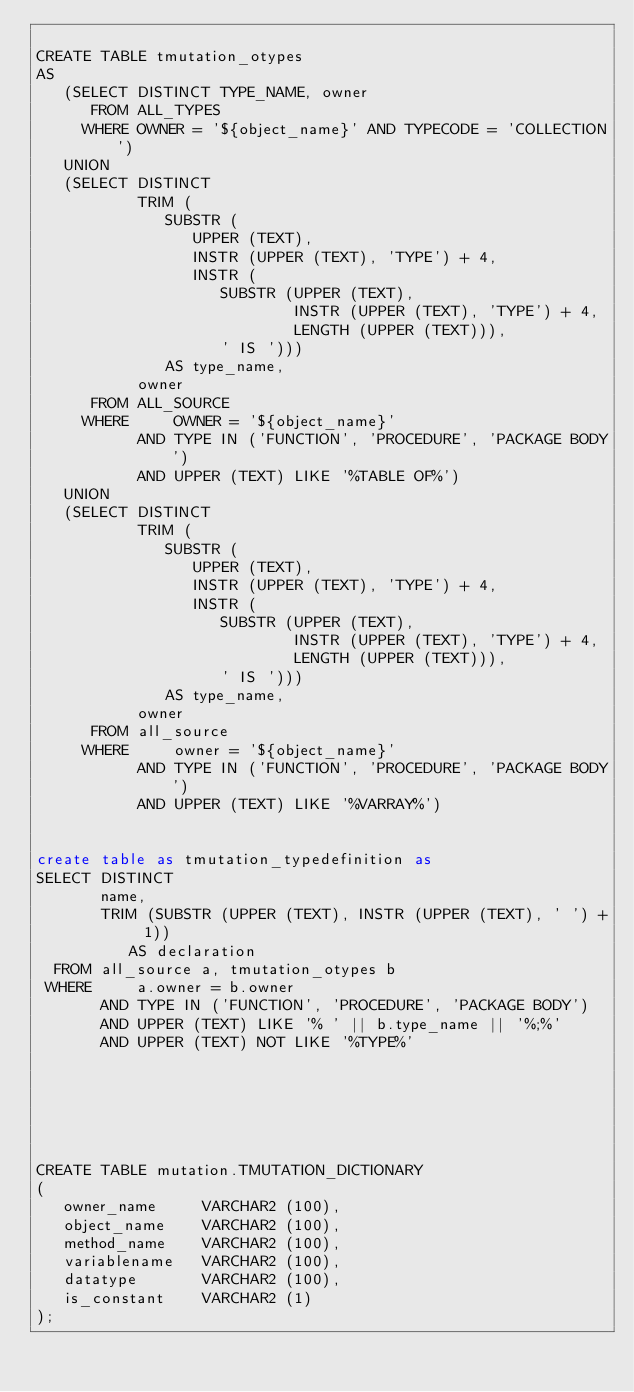<code> <loc_0><loc_0><loc_500><loc_500><_SQL_>
CREATE TABLE tmutation_otypes
AS
   (SELECT DISTINCT TYPE_NAME, owner
      FROM ALL_TYPES
     WHERE OWNER = '${object_name}' AND TYPECODE = 'COLLECTION')
   UNION
   (SELECT DISTINCT
           TRIM (
              SUBSTR (
                 UPPER (TEXT),
                 INSTR (UPPER (TEXT), 'TYPE') + 4,
                 INSTR (
                    SUBSTR (UPPER (TEXT),
                            INSTR (UPPER (TEXT), 'TYPE') + 4,
                            LENGTH (UPPER (TEXT))),
                    ' IS ')))
              AS type_name,
           owner
      FROM ALL_SOURCE
     WHERE     OWNER = '${object_name}'
           AND TYPE IN ('FUNCTION', 'PROCEDURE', 'PACKAGE BODY')
           AND UPPER (TEXT) LIKE '%TABLE OF%')
   UNION
   (SELECT DISTINCT
           TRIM (
              SUBSTR (
                 UPPER (TEXT),
                 INSTR (UPPER (TEXT), 'TYPE') + 4,
                 INSTR (
                    SUBSTR (UPPER (TEXT),
                            INSTR (UPPER (TEXT), 'TYPE') + 4,
                            LENGTH (UPPER (TEXT))),
                    ' IS ')))
              AS type_name,
           owner
      FROM all_source
     WHERE     owner = '${object_name}'
           AND TYPE IN ('FUNCTION', 'PROCEDURE', 'PACKAGE BODY')
           AND UPPER (TEXT) LIKE '%VARRAY%')
           
           
create table as tmutation_typedefinition as
SELECT DISTINCT
       name,
       TRIM (SUBSTR (UPPER (TEXT), INSTR (UPPER (TEXT), ' ') + 1))
          AS declaration
  FROM all_source a, tmutation_otypes b
 WHERE     a.owner = b.owner
       AND TYPE IN ('FUNCTION', 'PROCEDURE', 'PACKAGE BODY')
       AND UPPER (TEXT) LIKE '% ' || b.type_name || '%;%'
       AND UPPER (TEXT) NOT LIKE '%TYPE%'




 

CREATE TABLE mutation.TMUTATION_DICTIONARY
(
   owner_name     VARCHAR2 (100),
   object_name    VARCHAR2 (100),
   method_name    VARCHAR2 (100),
   variablename   VARCHAR2 (100),
   datatype       VARCHAR2 (100),
   is_constant    VARCHAR2 (1)
);

</code> 